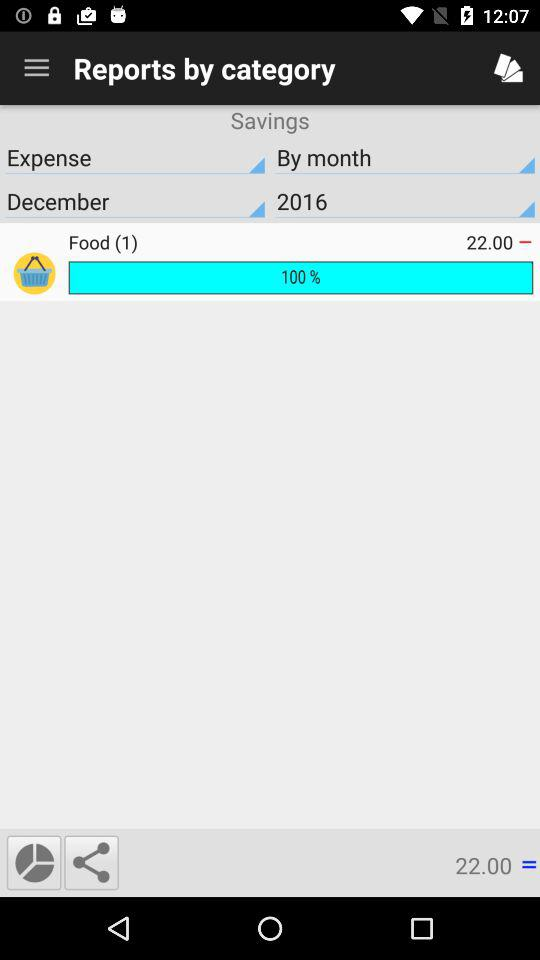What is the percentage? The percentage is 100. 